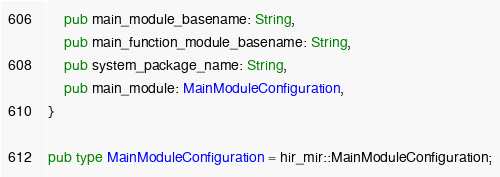<code> <loc_0><loc_0><loc_500><loc_500><_Rust_>    pub main_module_basename: String,
    pub main_function_module_basename: String,
    pub system_package_name: String,
    pub main_module: MainModuleConfiguration,
}

pub type MainModuleConfiguration = hir_mir::MainModuleConfiguration;
</code> 